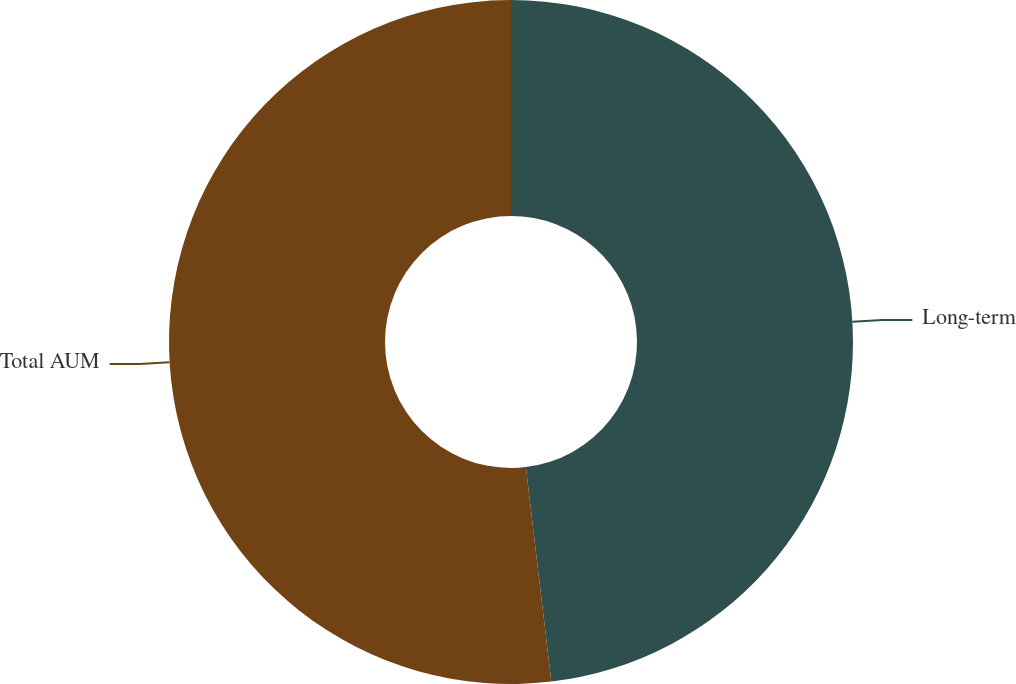Convert chart to OTSL. <chart><loc_0><loc_0><loc_500><loc_500><pie_chart><fcel>Long-term<fcel>Total AUM<nl><fcel>48.12%<fcel>51.88%<nl></chart> 